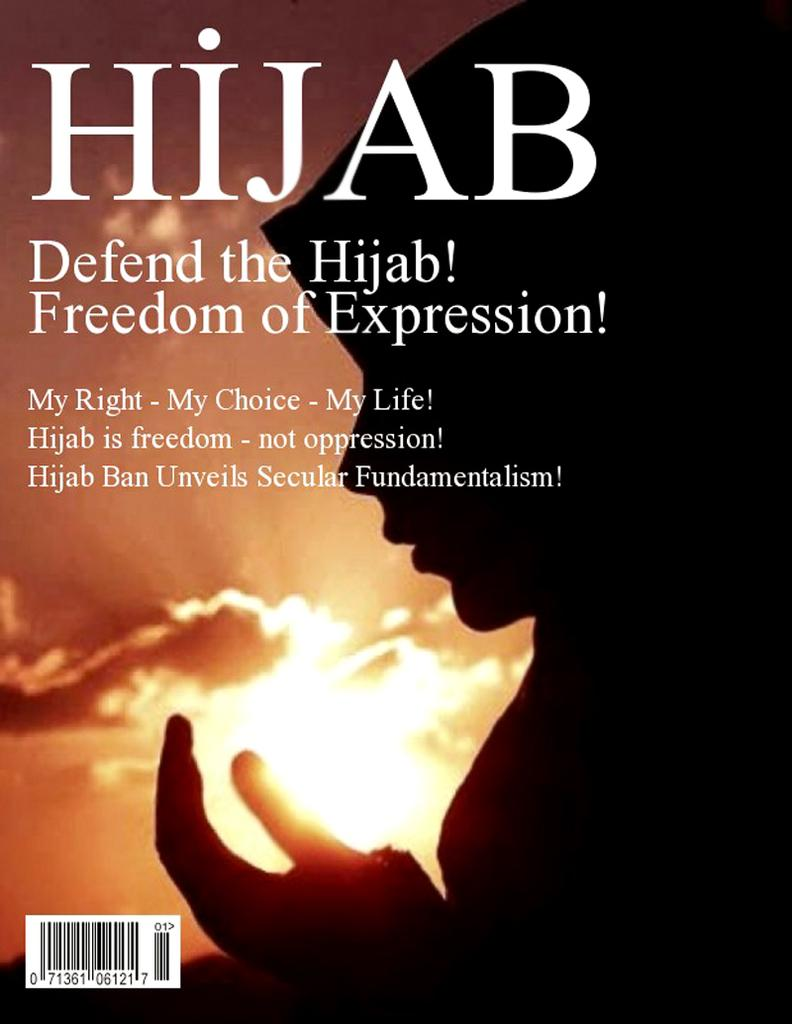<image>
Give a short and clear explanation of the subsequent image. A book that is titled Hijab Defend the Hjab! Freedom of Expression! 